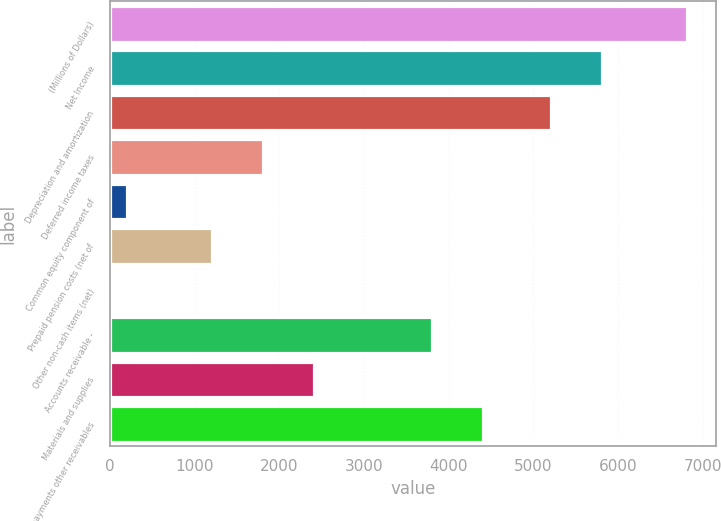Convert chart to OTSL. <chart><loc_0><loc_0><loc_500><loc_500><bar_chart><fcel>(Millions of Dollars)<fcel>Net Income<fcel>Depreciation and amortization<fcel>Deferred income taxes<fcel>Common equity component of<fcel>Prepaid pension costs (net of<fcel>Other non-cash items (net)<fcel>Accounts receivable -<fcel>Materials and supplies<fcel>Prepayments other receivables<nl><fcel>6812.2<fcel>5810.7<fcel>5209.8<fcel>1804.7<fcel>202.3<fcel>1203.8<fcel>2<fcel>3807.7<fcel>2405.6<fcel>4408.6<nl></chart> 